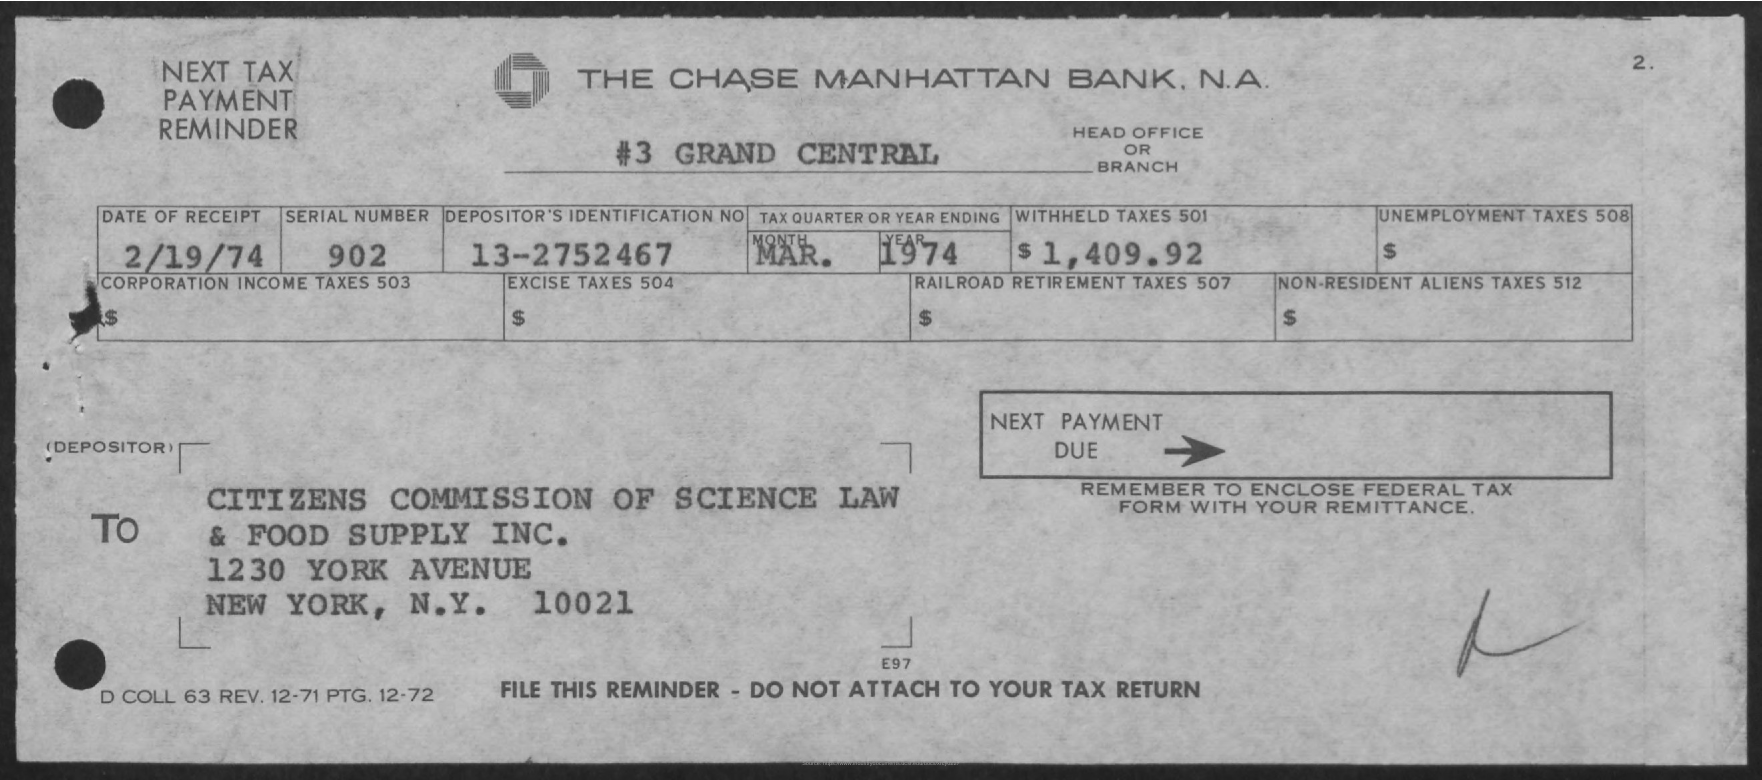What is the name of the bank
Your answer should be compact. The chase Manhattan Bank  N.A. What is the name of head office or branch
Offer a terse response. #3 grand central. What is the date of receipt ?
Give a very brief answer. 2/19/74. What is the serial number ?
Ensure brevity in your answer.  902. How much is the withheld taxes  501
Your response must be concise. $1,409.92. What is the depositor's identification no
Offer a very short reply. 13-2752467. What is the city name mentioned in the to address
Your answer should be very brief. New york. 